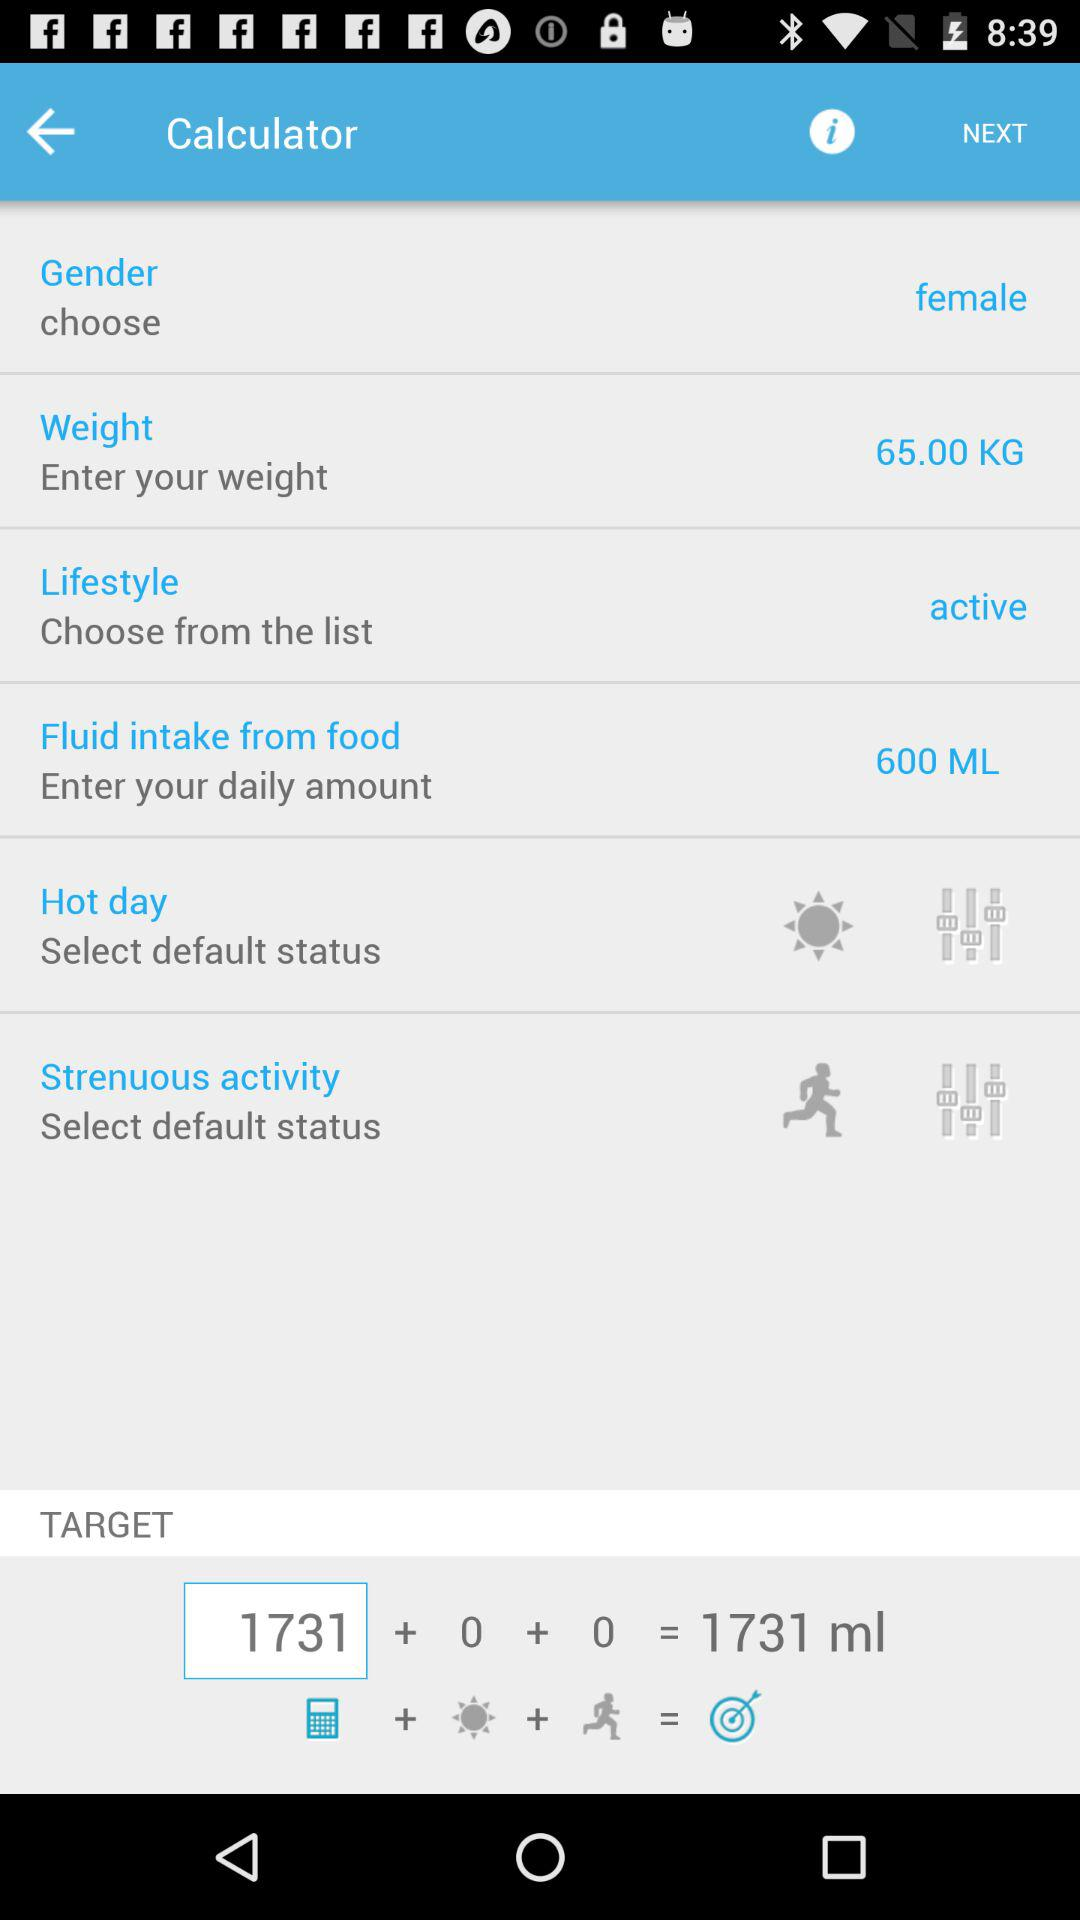How much is the weight? The weight is 65 kg. 